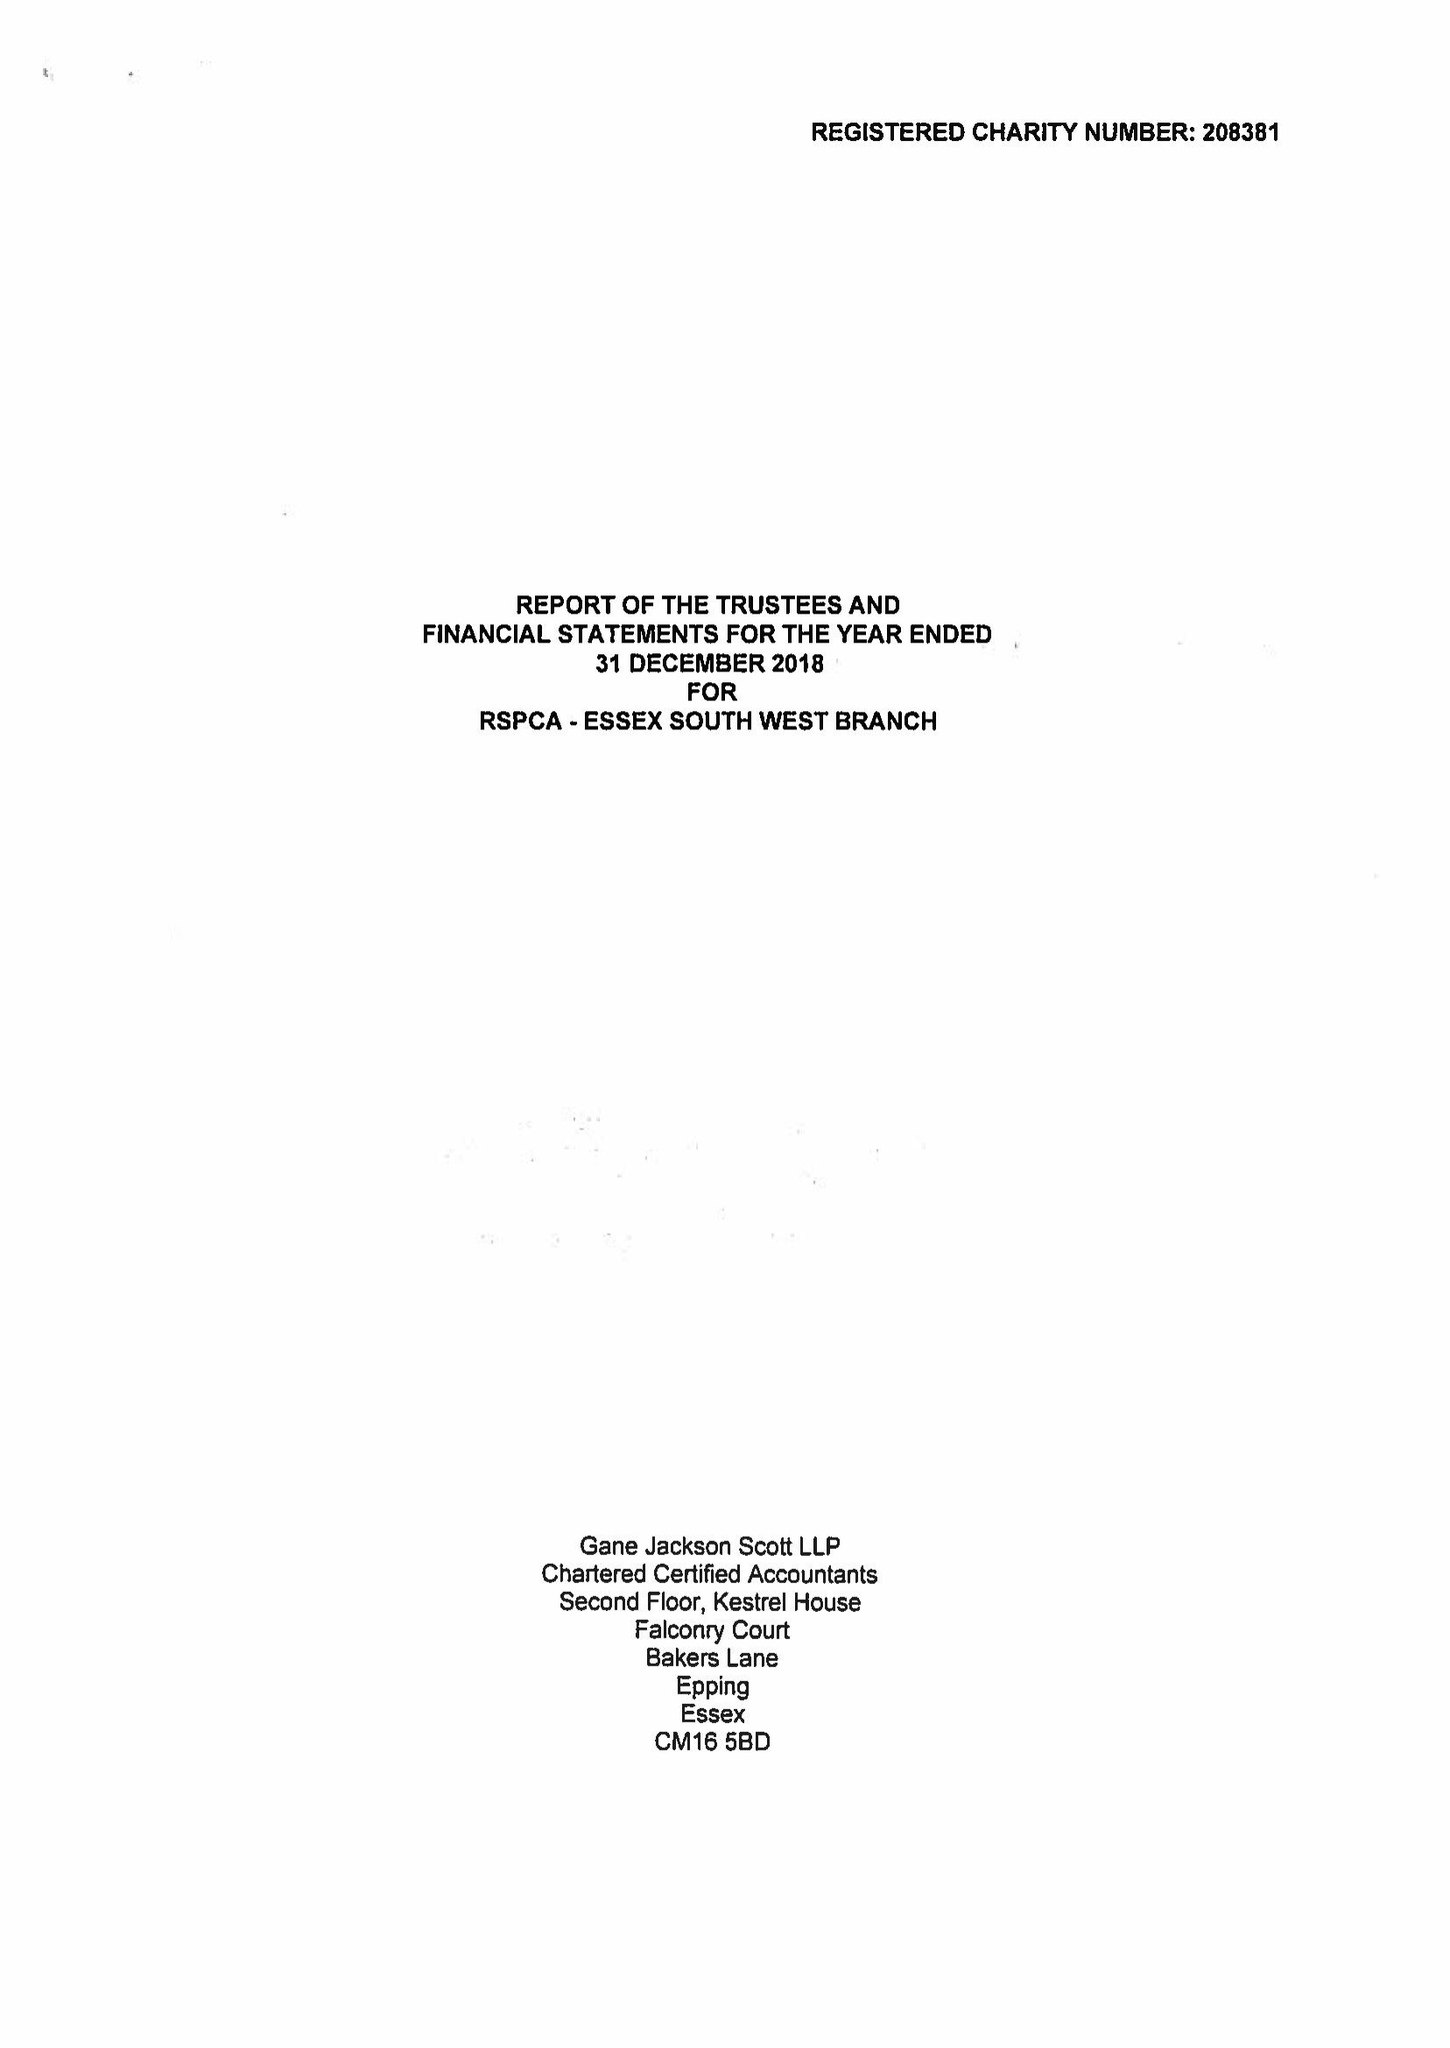What is the value for the address__street_line?
Answer the question using a single word or phrase. 103 HIGH ROAD 